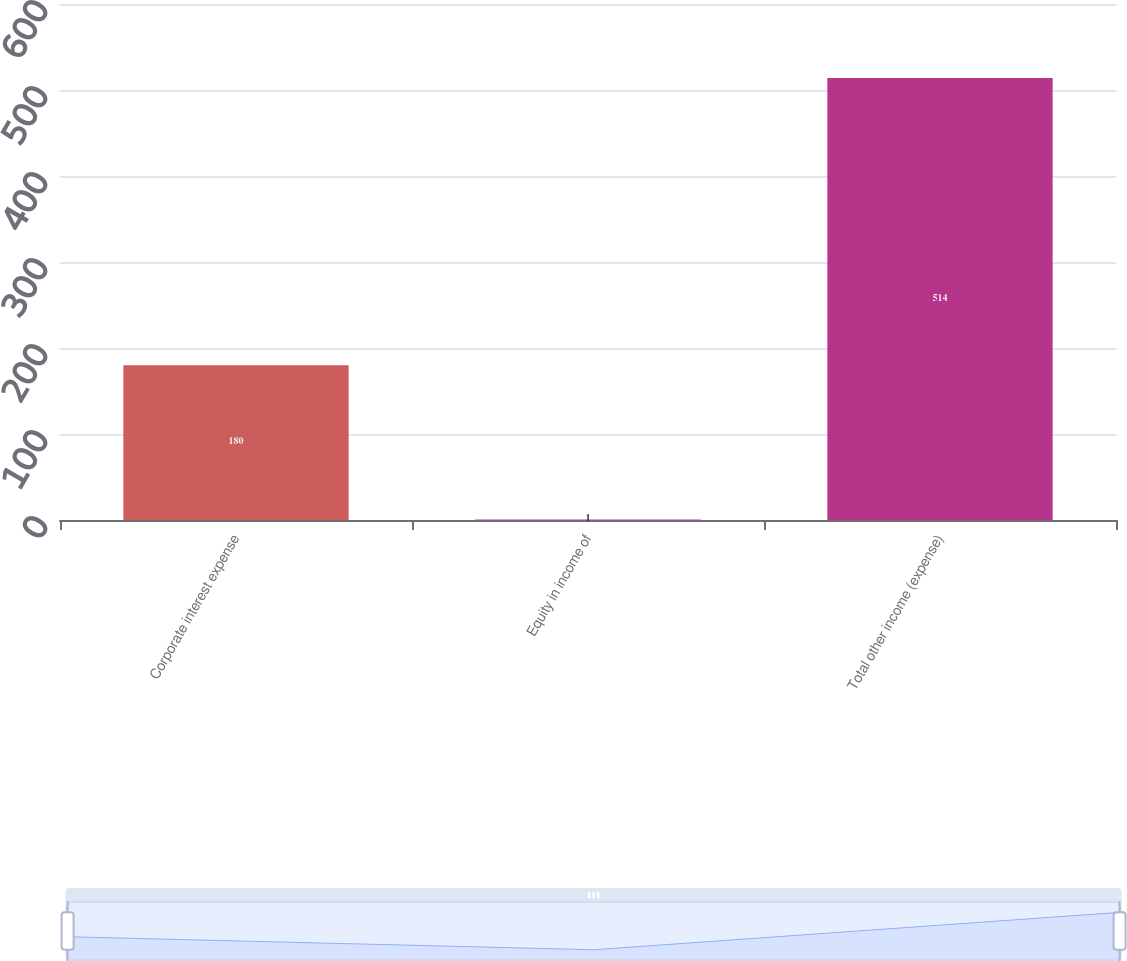Convert chart. <chart><loc_0><loc_0><loc_500><loc_500><bar_chart><fcel>Corporate interest expense<fcel>Equity in income of<fcel>Total other income (expense)<nl><fcel>180<fcel>1<fcel>514<nl></chart> 